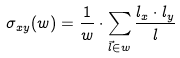Convert formula to latex. <formula><loc_0><loc_0><loc_500><loc_500>\sigma _ { x y } ( w ) = \frac { 1 } { w } \cdot \sum _ { \vec { l } \in w } \frac { l _ { x } \cdot l _ { y } } { l }</formula> 